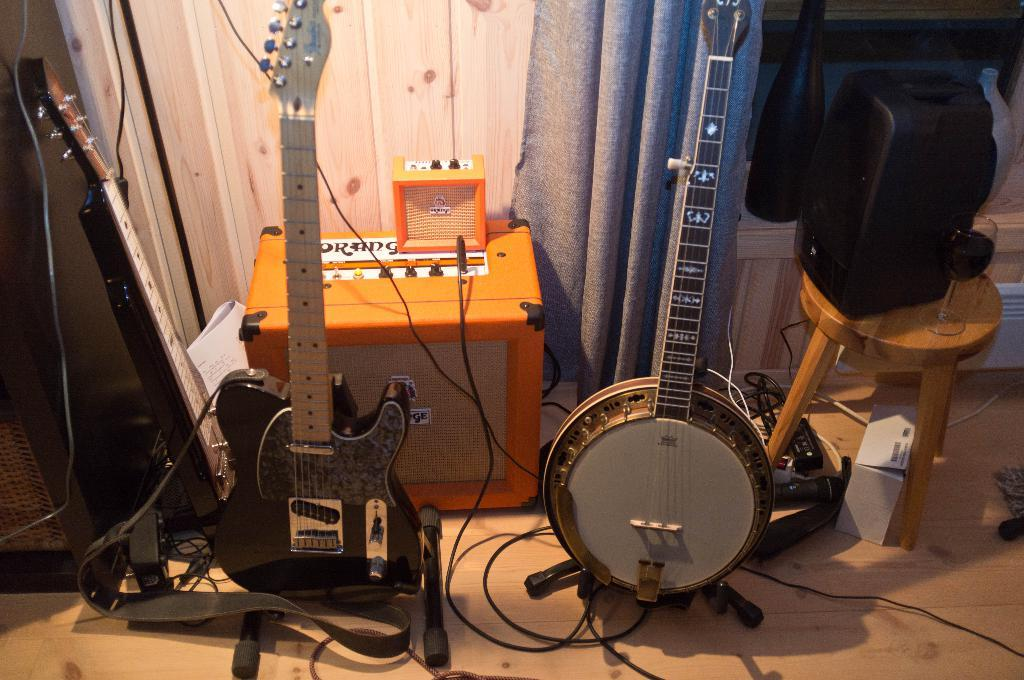What type of musical instruments are present in the image? There are guitars in the image. Can you describe any other objects related to music in the image? There is a cable and a speaker on the table in the image. What is the background of the image like? There is a curtain in the background of the image. What is on the table in the image? There is a speaker and a glass on the table. What type of surface is visible in the image? There is a floor visible in the image. What type of authority figure can be seen in the image? There is no authority figure present in the image; it features guitars, a cable, a speaker, a glass, a curtain, and a floor. How many houses are visible in the image? There are no houses visible in the image. 